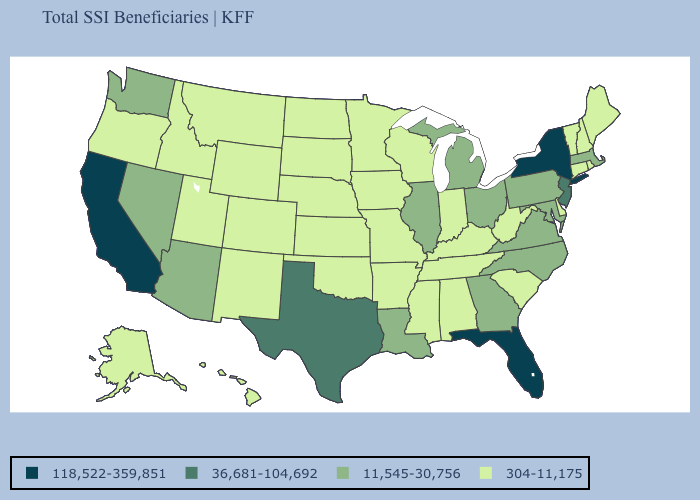What is the lowest value in the USA?
Concise answer only. 304-11,175. Does Oklahoma have a lower value than Iowa?
Concise answer only. No. Name the states that have a value in the range 304-11,175?
Quick response, please. Alabama, Alaska, Arkansas, Colorado, Connecticut, Delaware, Hawaii, Idaho, Indiana, Iowa, Kansas, Kentucky, Maine, Minnesota, Mississippi, Missouri, Montana, Nebraska, New Hampshire, New Mexico, North Dakota, Oklahoma, Oregon, Rhode Island, South Carolina, South Dakota, Tennessee, Utah, Vermont, West Virginia, Wisconsin, Wyoming. What is the value of Wyoming?
Quick response, please. 304-11,175. Does Massachusetts have a lower value than Louisiana?
Answer briefly. No. Does the first symbol in the legend represent the smallest category?
Short answer required. No. What is the value of Utah?
Give a very brief answer. 304-11,175. What is the value of California?
Short answer required. 118,522-359,851. Name the states that have a value in the range 304-11,175?
Short answer required. Alabama, Alaska, Arkansas, Colorado, Connecticut, Delaware, Hawaii, Idaho, Indiana, Iowa, Kansas, Kentucky, Maine, Minnesota, Mississippi, Missouri, Montana, Nebraska, New Hampshire, New Mexico, North Dakota, Oklahoma, Oregon, Rhode Island, South Carolina, South Dakota, Tennessee, Utah, Vermont, West Virginia, Wisconsin, Wyoming. What is the value of Utah?
Short answer required. 304-11,175. How many symbols are there in the legend?
Keep it brief. 4. What is the value of North Carolina?
Short answer required. 11,545-30,756. Which states hav the highest value in the South?
Be succinct. Florida. Name the states that have a value in the range 36,681-104,692?
Give a very brief answer. New Jersey, Texas. Name the states that have a value in the range 11,545-30,756?
Be succinct. Arizona, Georgia, Illinois, Louisiana, Maryland, Massachusetts, Michigan, Nevada, North Carolina, Ohio, Pennsylvania, Virginia, Washington. 